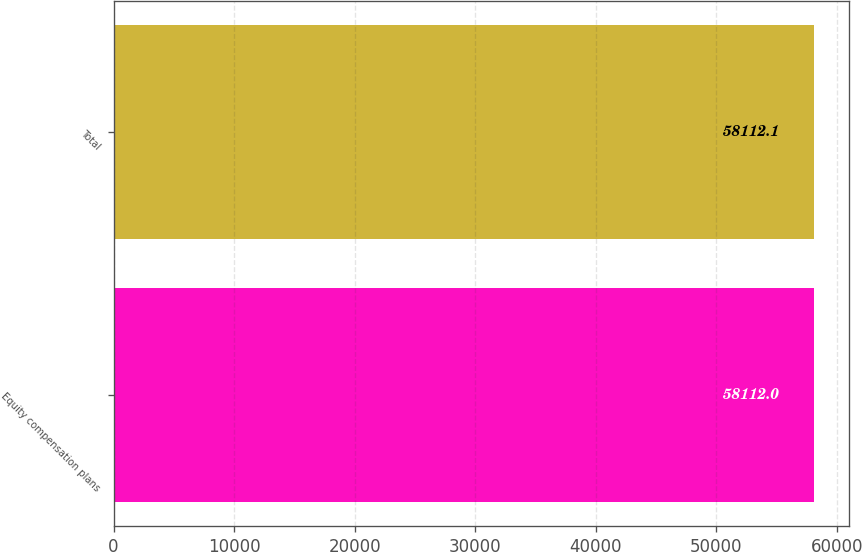<chart> <loc_0><loc_0><loc_500><loc_500><bar_chart><fcel>Equity compensation plans<fcel>Total<nl><fcel>58112<fcel>58112.1<nl></chart> 